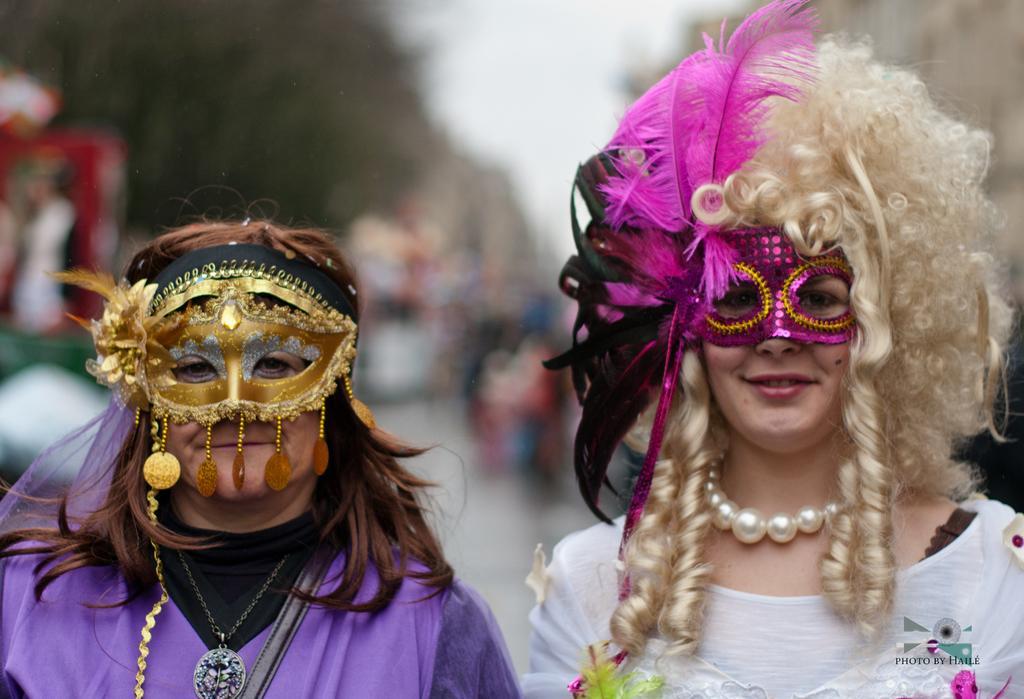In one or two sentences, can you explain what this image depicts? In this image we can see two persons wearing costume and mask to their faces and they are posing for a photo and in the background the image is blurred. 